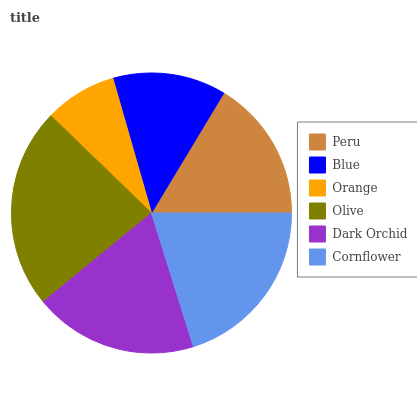Is Orange the minimum?
Answer yes or no. Yes. Is Olive the maximum?
Answer yes or no. Yes. Is Blue the minimum?
Answer yes or no. No. Is Blue the maximum?
Answer yes or no. No. Is Peru greater than Blue?
Answer yes or no. Yes. Is Blue less than Peru?
Answer yes or no. Yes. Is Blue greater than Peru?
Answer yes or no. No. Is Peru less than Blue?
Answer yes or no. No. Is Dark Orchid the high median?
Answer yes or no. Yes. Is Peru the low median?
Answer yes or no. Yes. Is Peru the high median?
Answer yes or no. No. Is Cornflower the low median?
Answer yes or no. No. 